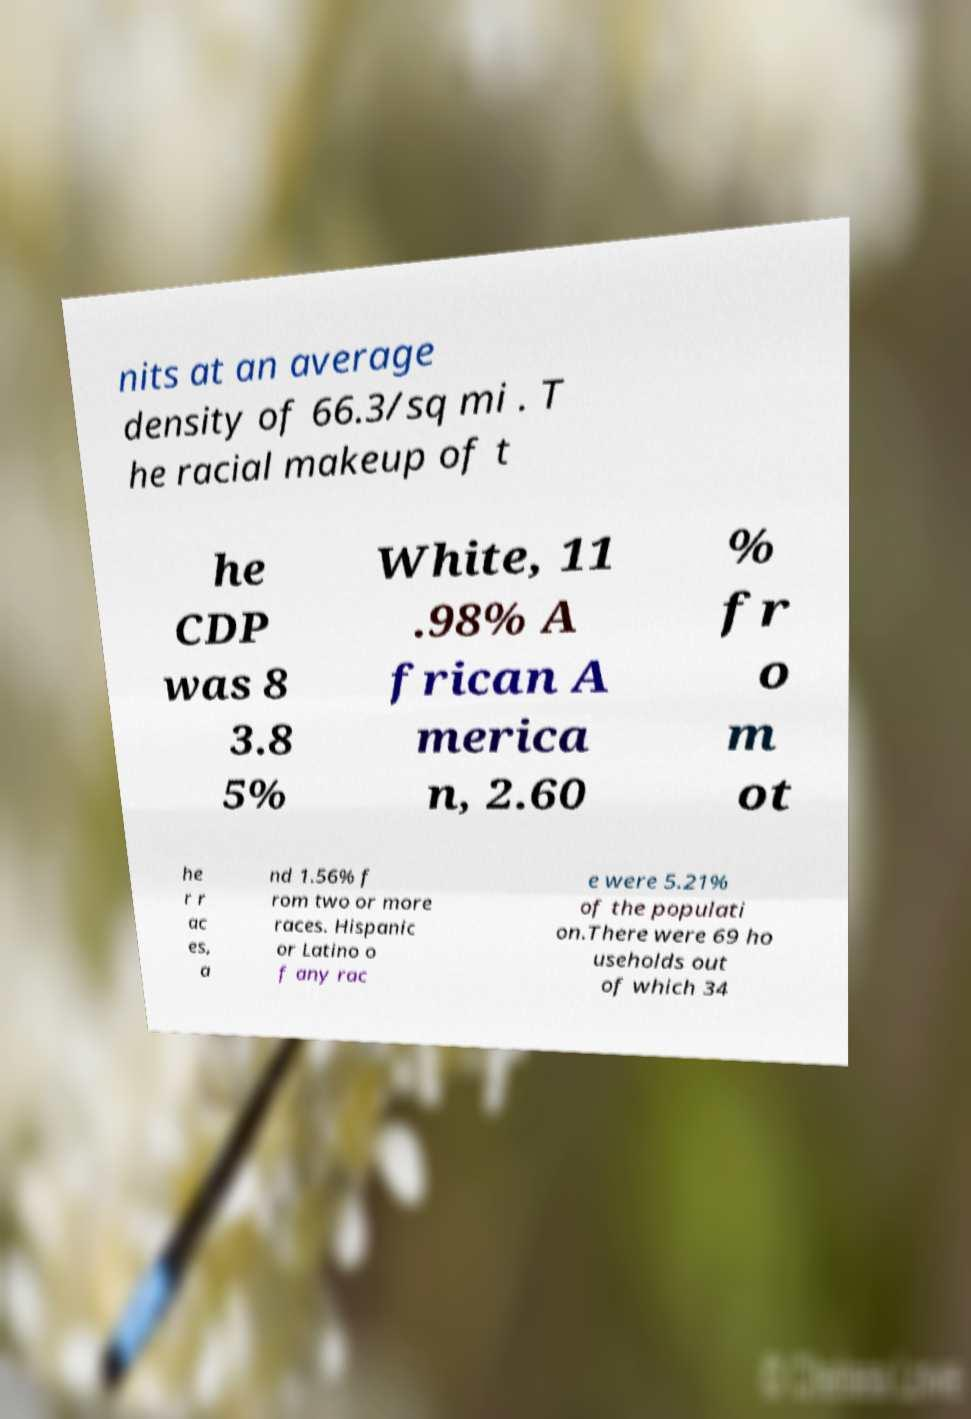Can you read and provide the text displayed in the image?This photo seems to have some interesting text. Can you extract and type it out for me? nits at an average density of 66.3/sq mi . T he racial makeup of t he CDP was 8 3.8 5% White, 11 .98% A frican A merica n, 2.60 % fr o m ot he r r ac es, a nd 1.56% f rom two or more races. Hispanic or Latino o f any rac e were 5.21% of the populati on.There were 69 ho useholds out of which 34 